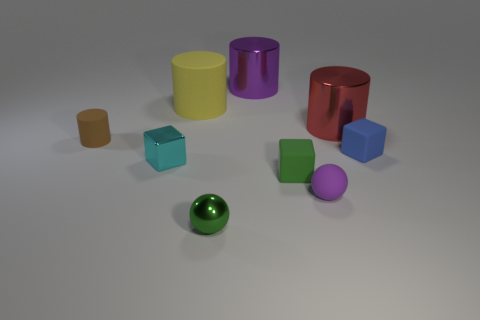Which object stands out the most due to its unique shape? The object that stands out due to its unique shape is the red 'U' shaped object. Unlike the other geometrically regular objects, it has an open-ended structure with a curved interior, which makes it quite distinctive. What could be a possible use for this 'U' shaped object in this set? The 'U' shaped object could be envisioned as a stand or a holder within the context of this set. Its curved and open form could be ideal for cradling a cylindrical object or for use in a physics demonstration about balance and center of gravity. 